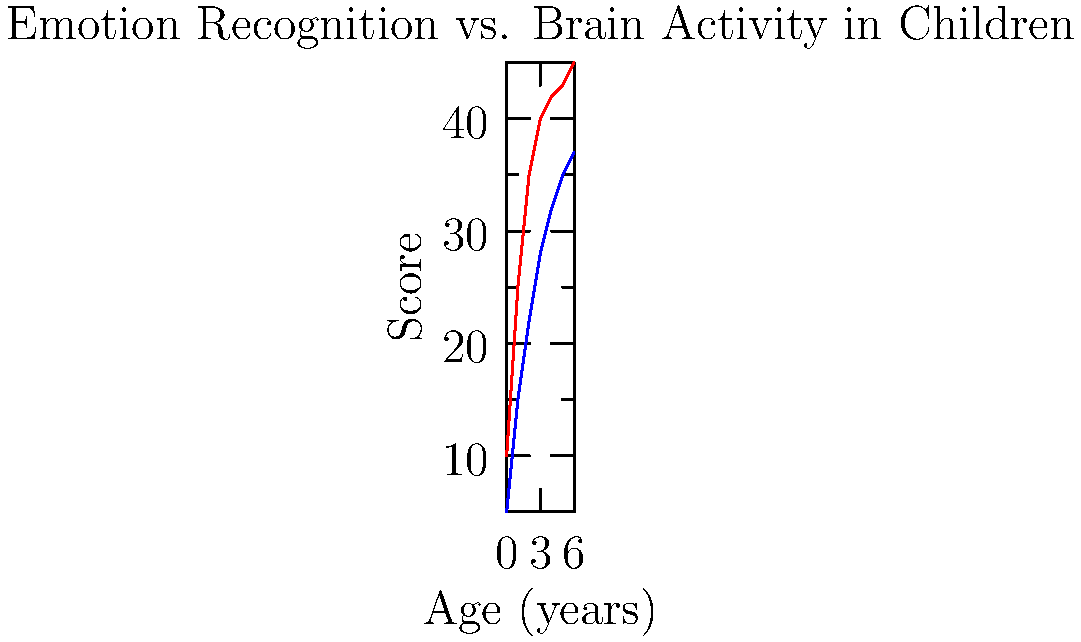Based on the graph, which of the following statements is most accurate regarding the relationship between emotion recognition accuracy and brain activity in children aged 0-6 years? To answer this question, we need to analyze the trends in both lines on the graph:

1. The red line represents Emotion Recognition Accuracy.
2. The blue line represents Brain Activity (fMRI).

Let's examine the characteristics of each line:

1. Emotion Recognition Accuracy (red line):
   - Starts at a higher point than Brain Activity
   - Increases rapidly from age 0 to 3
   - The rate of increase slows down from age 3 to 6

2. Brain Activity (blue line):
   - Starts at a lower point than Emotion Recognition Accuracy
   - Increases steadily from age 0 to 6
   - The rate of increase is more consistent compared to Emotion Recognition Accuracy

Comparing the two lines:
- Both show an overall increase with age
- The gap between the two lines is largest at the beginning (age 0) and narrows as age increases
- The rate of increase for Emotion Recognition Accuracy slows down more noticeably than Brain Activity

Given these observations, we can conclude that both emotion recognition accuracy and brain activity increase with age, but emotion recognition accuracy shows a more pronounced initial increase followed by a plateau, while brain activity demonstrates a more steady increase throughout the age range.
Answer: Both increase with age, but emotion recognition accuracy plateaus while brain activity shows steady growth. 